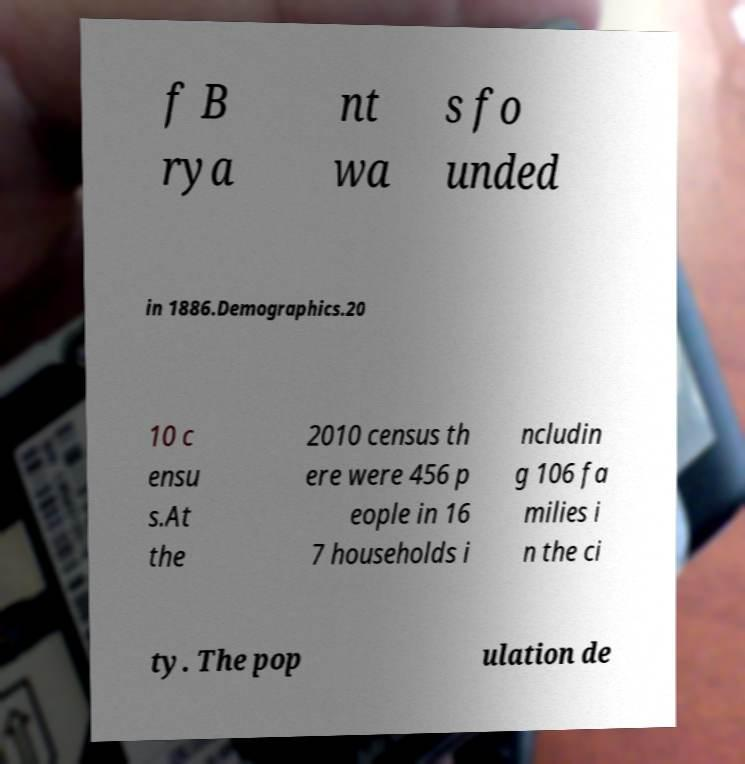There's text embedded in this image that I need extracted. Can you transcribe it verbatim? f B rya nt wa s fo unded in 1886.Demographics.20 10 c ensu s.At the 2010 census th ere were 456 p eople in 16 7 households i ncludin g 106 fa milies i n the ci ty. The pop ulation de 